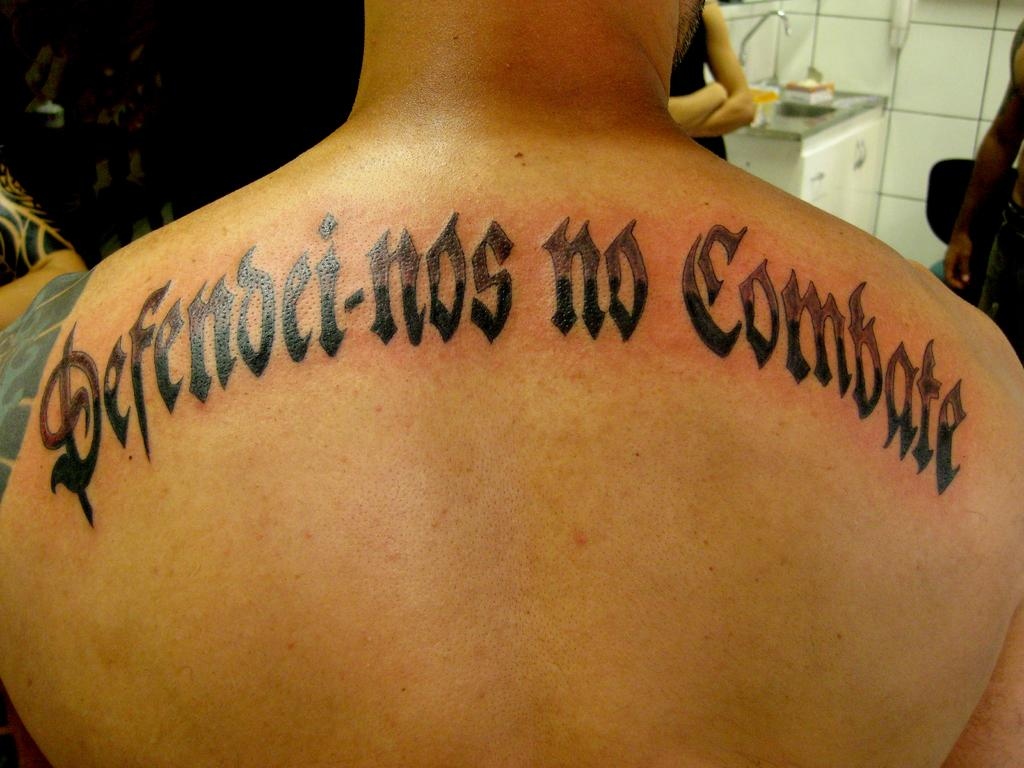What is a notable feature of the person in the image? There is a person with a tattoo in the image. How are the people in the image positioned? There are people in front of the tattooed person. What can be seen on the table in the image? There is a table with objects in the image. What is visible in the background of the image? There is a wall visible in the background of the image. What type of oatmeal is being served to the pig in the image? There is no pig or oatmeal present in the image. 